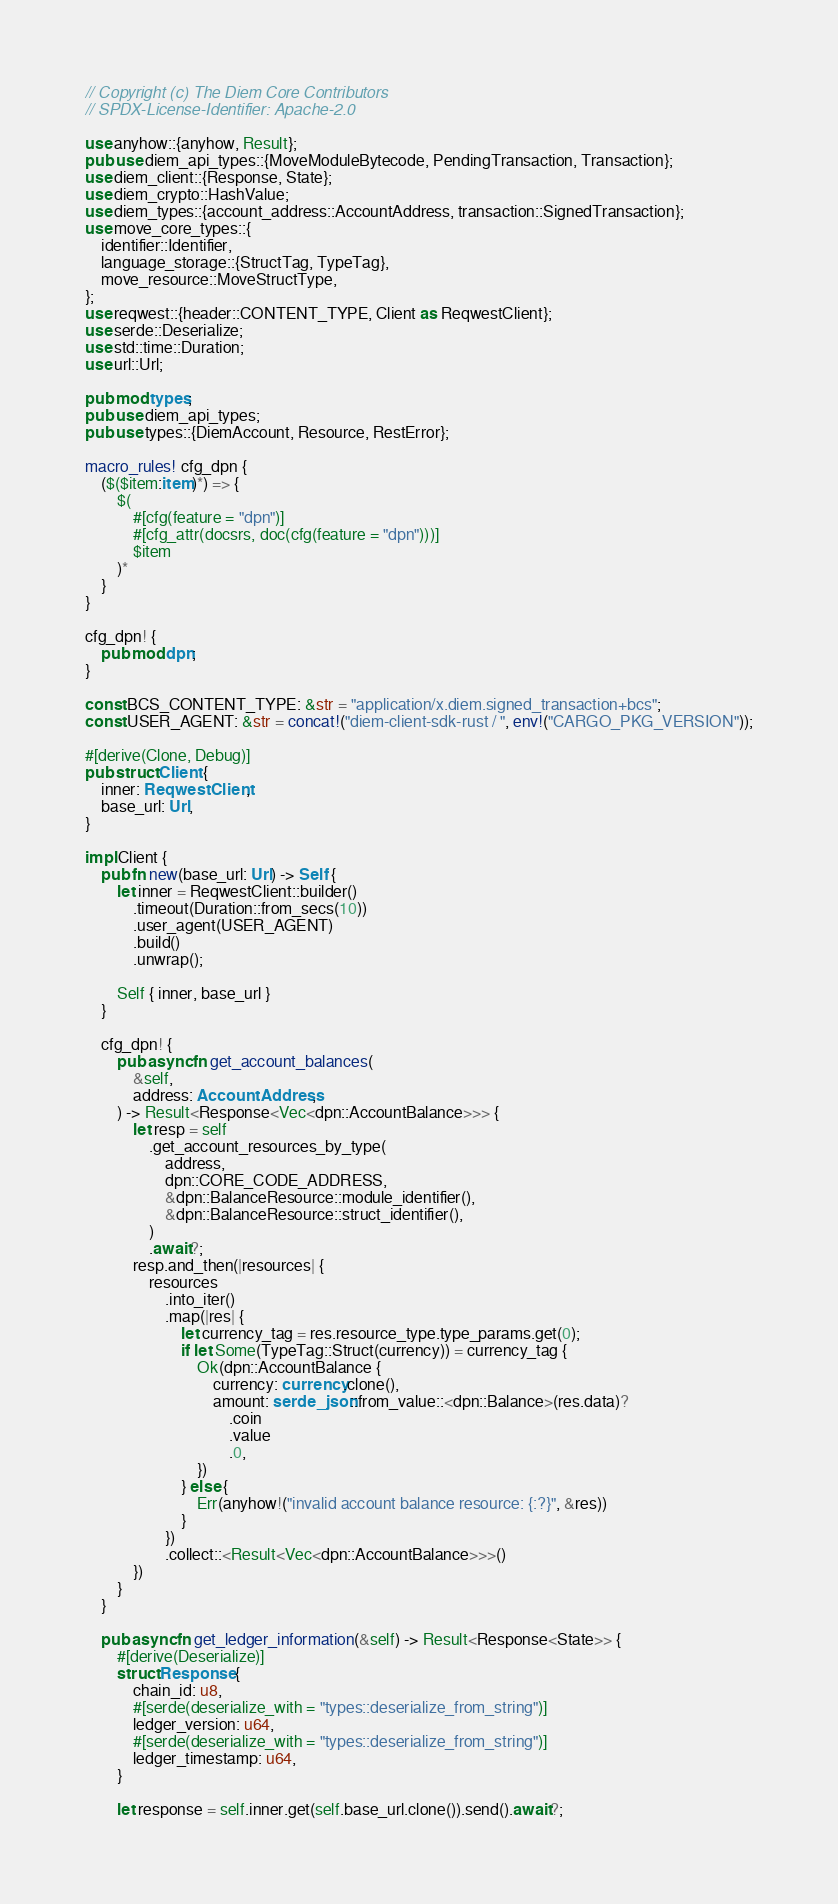<code> <loc_0><loc_0><loc_500><loc_500><_Rust_>// Copyright (c) The Diem Core Contributors
// SPDX-License-Identifier: Apache-2.0

use anyhow::{anyhow, Result};
pub use diem_api_types::{MoveModuleBytecode, PendingTransaction, Transaction};
use diem_client::{Response, State};
use diem_crypto::HashValue;
use diem_types::{account_address::AccountAddress, transaction::SignedTransaction};
use move_core_types::{
    identifier::Identifier,
    language_storage::{StructTag, TypeTag},
    move_resource::MoveStructType,
};
use reqwest::{header::CONTENT_TYPE, Client as ReqwestClient};
use serde::Deserialize;
use std::time::Duration;
use url::Url;

pub mod types;
pub use diem_api_types;
pub use types::{DiemAccount, Resource, RestError};

macro_rules! cfg_dpn {
    ($($item:item)*) => {
        $(
            #[cfg(feature = "dpn")]
            #[cfg_attr(docsrs, doc(cfg(feature = "dpn")))]
            $item
        )*
    }
}

cfg_dpn! {
    pub mod dpn;
}

const BCS_CONTENT_TYPE: &str = "application/x.diem.signed_transaction+bcs";
const USER_AGENT: &str = concat!("diem-client-sdk-rust / ", env!("CARGO_PKG_VERSION"));

#[derive(Clone, Debug)]
pub struct Client {
    inner: ReqwestClient,
    base_url: Url,
}

impl Client {
    pub fn new(base_url: Url) -> Self {
        let inner = ReqwestClient::builder()
            .timeout(Duration::from_secs(10))
            .user_agent(USER_AGENT)
            .build()
            .unwrap();

        Self { inner, base_url }
    }

    cfg_dpn! {
        pub async fn get_account_balances(
            &self,
            address: AccountAddress,
        ) -> Result<Response<Vec<dpn::AccountBalance>>> {
            let resp = self
                .get_account_resources_by_type(
                    address,
                    dpn::CORE_CODE_ADDRESS,
                    &dpn::BalanceResource::module_identifier(),
                    &dpn::BalanceResource::struct_identifier(),
                )
                .await?;
            resp.and_then(|resources| {
                resources
                    .into_iter()
                    .map(|res| {
                        let currency_tag = res.resource_type.type_params.get(0);
                        if let Some(TypeTag::Struct(currency)) = currency_tag {
                            Ok(dpn::AccountBalance {
                                currency: currency.clone(),
                                amount: serde_json::from_value::<dpn::Balance>(res.data)?
                                    .coin
                                    .value
                                    .0,
                            })
                        } else {
                            Err(anyhow!("invalid account balance resource: {:?}", &res))
                        }
                    })
                    .collect::<Result<Vec<dpn::AccountBalance>>>()
            })
        }
    }

    pub async fn get_ledger_information(&self) -> Result<Response<State>> {
        #[derive(Deserialize)]
        struct Response {
            chain_id: u8,
            #[serde(deserialize_with = "types::deserialize_from_string")]
            ledger_version: u64,
            #[serde(deserialize_with = "types::deserialize_from_string")]
            ledger_timestamp: u64,
        }

        let response = self.inner.get(self.base_url.clone()).send().await?;
</code> 